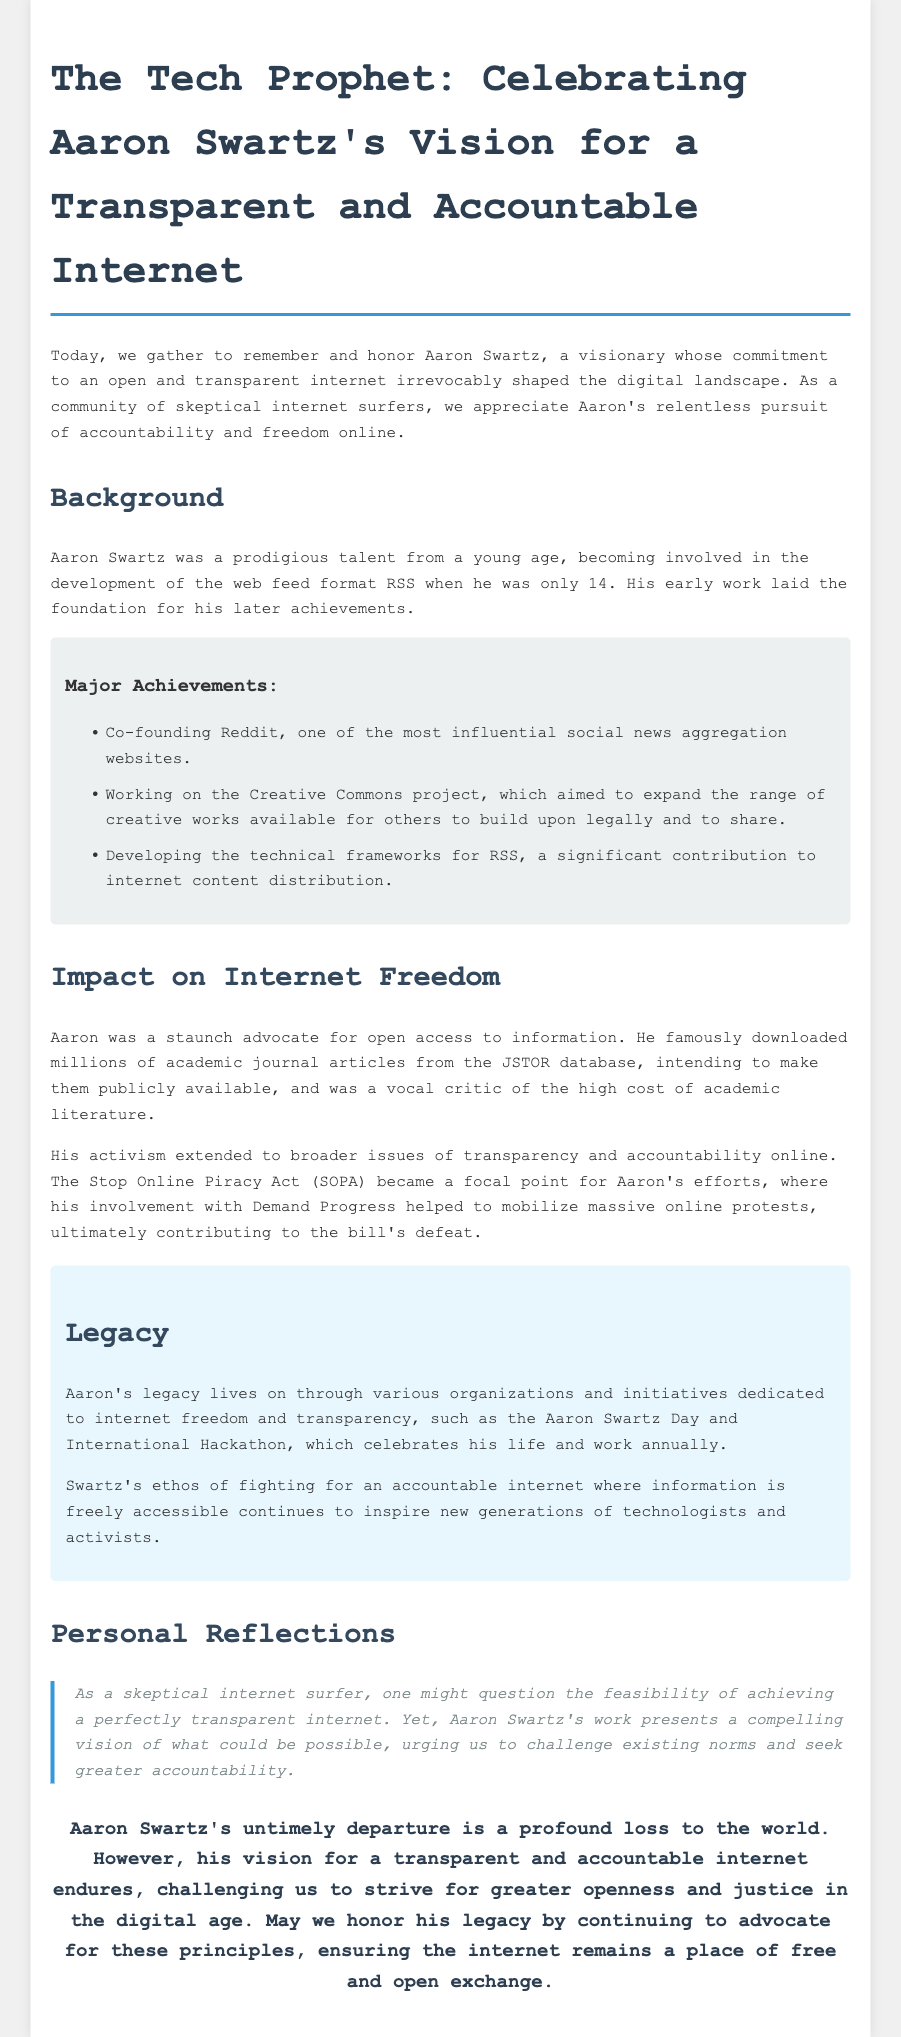what was Aaron Swartz's age when he became involved with RSS? The document states he was only 14 years old when he became involved in the development of the web feed format RSS.
Answer: 14 what major website did Aaron co-found? The document mentions that Aaron co-founded Reddit, one of the most influential social news aggregation websites.
Answer: Reddit what is the purpose of Creative Commons? The document explains that Creative Commons aimed to expand the range of creative works available for others to build upon legally and to share.
Answer: Expand creative works which act did Aaron mobilize protests against? According to the document, Aaron's activism included opposition to the Stop Online Piracy Act (SOPA).
Answer: SOPA what annual event celebrates Aaron Swartz's life and work? The document mentions the Aaron Swartz Day and International Hackathon as the event celebrating his life and work.
Answer: Aaron Swartz Day what was a core value that Aaron Swartz fought for? The document emphasizes that he was a staunch advocate for open access to information.
Answer: Open access how did Aaron Swartz's activism influence SOPA? The document indicates that his involvement helped to mobilize massive online protests, contributing to the bill's defeat.
Answer: Mobilized protests what does the quote in Personal Reflections express? The quote articulates a challenge to existing norms and seeks greater accountability in achieving a transparent internet.
Answer: Challenge norms 